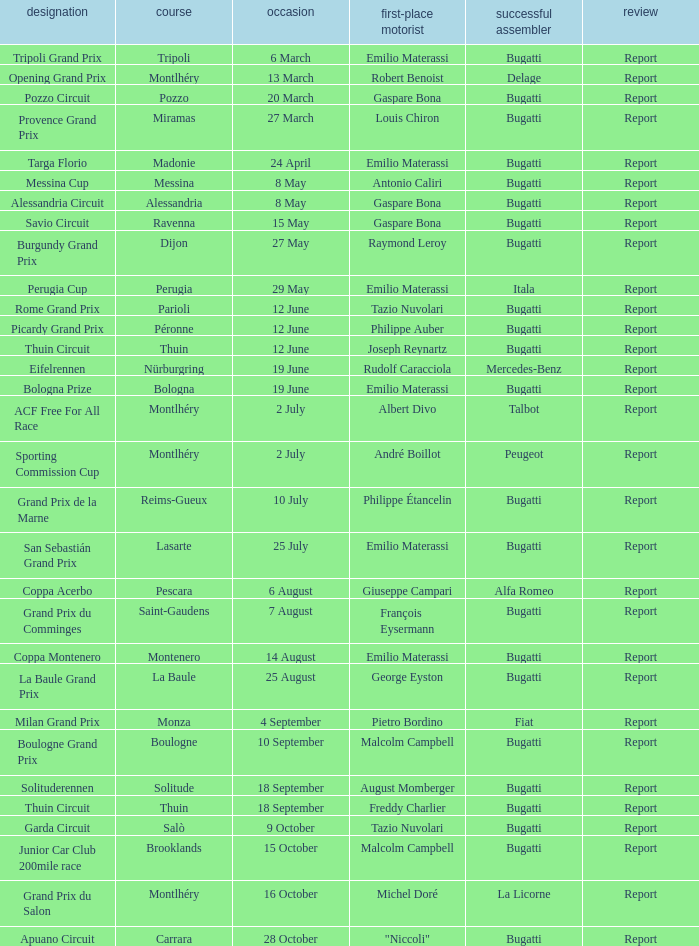When did Gaspare Bona win the Pozzo Circuit? 20 March. 